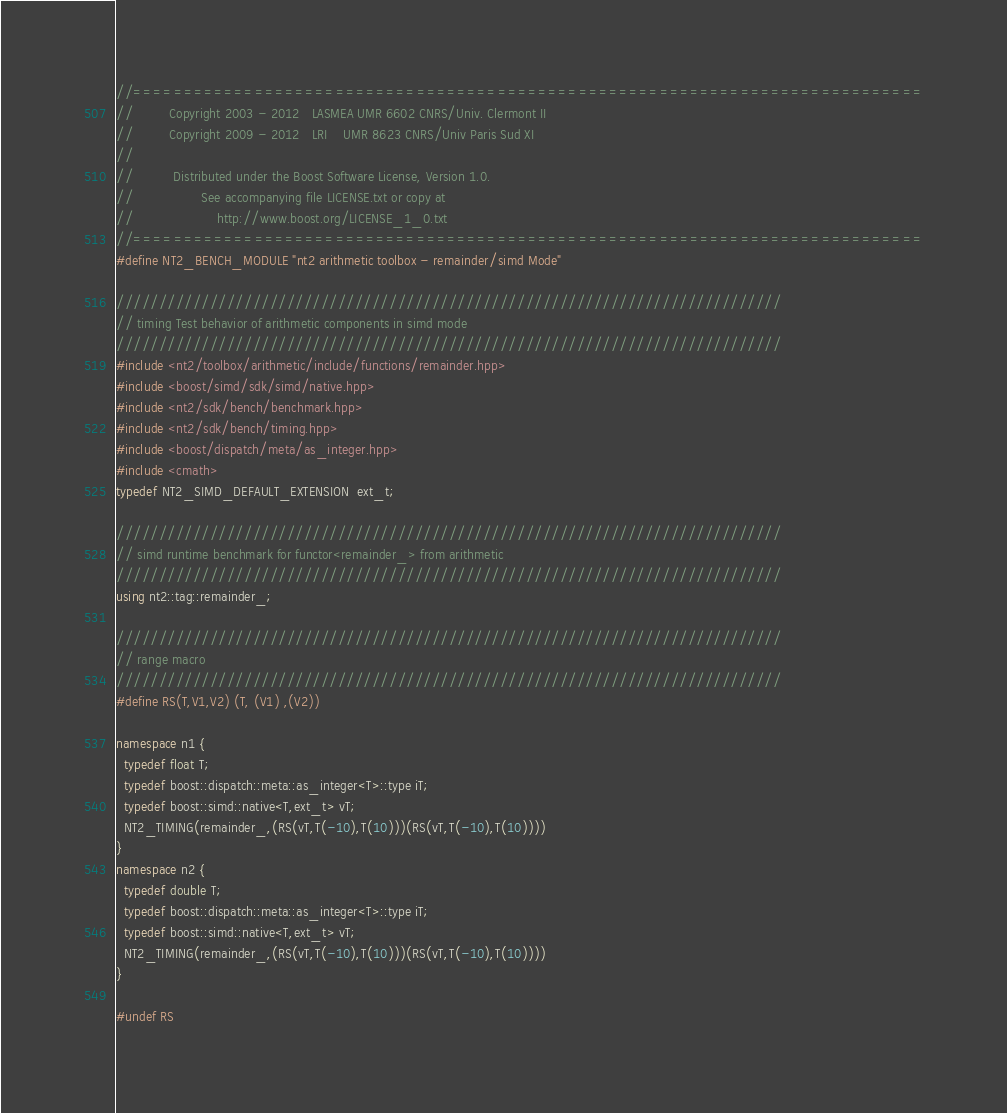Convert code to text. <code><loc_0><loc_0><loc_500><loc_500><_C++_>//==============================================================================
//         Copyright 2003 - 2012   LASMEA UMR 6602 CNRS/Univ. Clermont II
//         Copyright 2009 - 2012   LRI    UMR 8623 CNRS/Univ Paris Sud XI
//
//          Distributed under the Boost Software License, Version 1.0.
//                 See accompanying file LICENSE.txt or copy at
//                     http://www.boost.org/LICENSE_1_0.txt
//==============================================================================
#define NT2_BENCH_MODULE "nt2 arithmetic toolbox - remainder/simd Mode"

//////////////////////////////////////////////////////////////////////////////
// timing Test behavior of arithmetic components in simd mode
//////////////////////////////////////////////////////////////////////////////
#include <nt2/toolbox/arithmetic/include/functions/remainder.hpp>
#include <boost/simd/sdk/simd/native.hpp>
#include <nt2/sdk/bench/benchmark.hpp>
#include <nt2/sdk/bench/timing.hpp>
#include <boost/dispatch/meta/as_integer.hpp>
#include <cmath>
typedef NT2_SIMD_DEFAULT_EXTENSION  ext_t;

//////////////////////////////////////////////////////////////////////////////
// simd runtime benchmark for functor<remainder_> from arithmetic
//////////////////////////////////////////////////////////////////////////////
using nt2::tag::remainder_;

//////////////////////////////////////////////////////////////////////////////
// range macro
//////////////////////////////////////////////////////////////////////////////
#define RS(T,V1,V2) (T, (V1) ,(V2))

namespace n1 {
  typedef float T;
  typedef boost::dispatch::meta::as_integer<T>::type iT;
  typedef boost::simd::native<T,ext_t> vT;
  NT2_TIMING(remainder_,(RS(vT,T(-10),T(10)))(RS(vT,T(-10),T(10))))
}
namespace n2 {
  typedef double T;
  typedef boost::dispatch::meta::as_integer<T>::type iT;
  typedef boost::simd::native<T,ext_t> vT;
  NT2_TIMING(remainder_,(RS(vT,T(-10),T(10)))(RS(vT,T(-10),T(10))))
}

#undef RS
</code> 